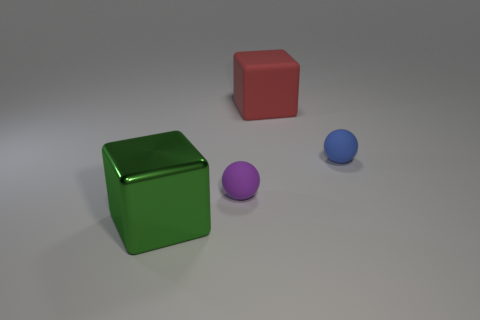Subtract all red blocks. How many blocks are left? 1 Add 2 purple rubber spheres. How many objects exist? 6 Subtract all gray spheres. How many yellow cubes are left? 0 Add 2 tiny blue matte things. How many tiny blue matte things are left? 3 Add 2 purple things. How many purple things exist? 3 Subtract 0 blue cubes. How many objects are left? 4 Subtract 1 cubes. How many cubes are left? 1 Subtract all gray cubes. Subtract all gray spheres. How many cubes are left? 2 Subtract all big red blocks. Subtract all metal blocks. How many objects are left? 2 